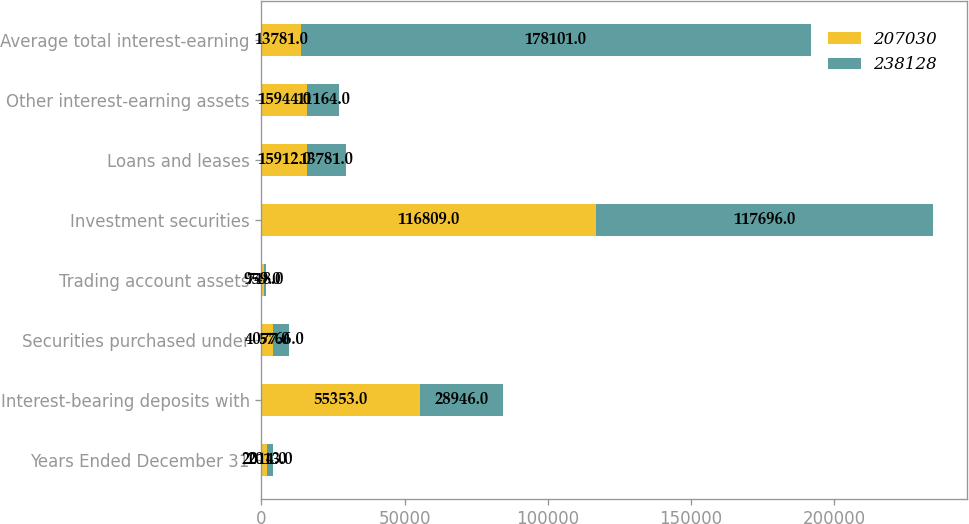Convert chart. <chart><loc_0><loc_0><loc_500><loc_500><stacked_bar_chart><ecel><fcel>Years Ended December 31<fcel>Interest-bearing deposits with<fcel>Securities purchased under<fcel>Trading account assets<fcel>Investment securities<fcel>Loans and leases<fcel>Other interest-earning assets<fcel>Average total interest-earning<nl><fcel>207030<fcel>2014<fcel>55353<fcel>4077<fcel>959<fcel>116809<fcel>15912<fcel>15944<fcel>13781<nl><fcel>238128<fcel>2013<fcel>28946<fcel>5766<fcel>748<fcel>117696<fcel>13781<fcel>11164<fcel>178101<nl></chart> 